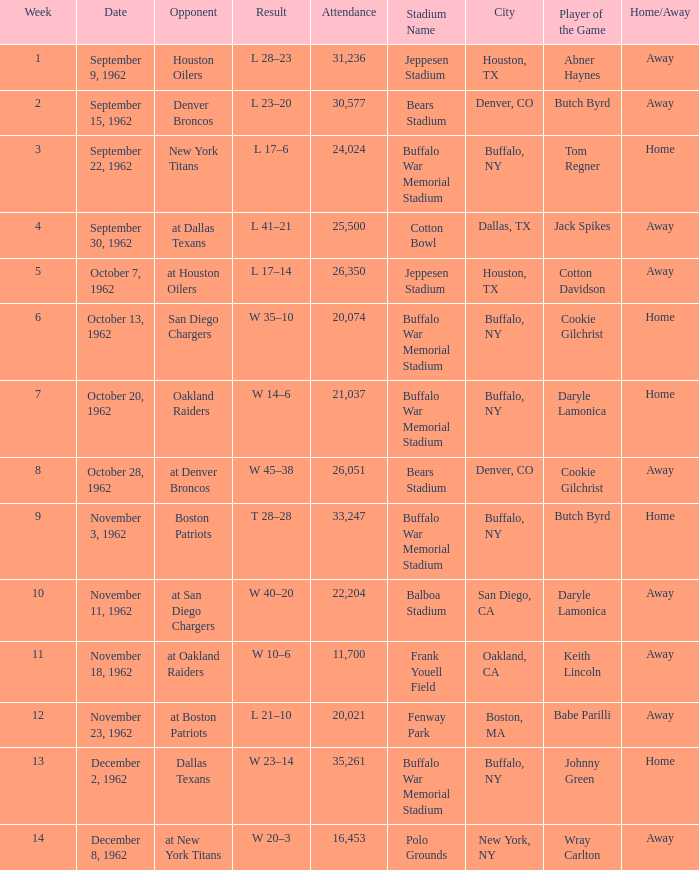What week was the attendance smaller than 22,204 on December 8, 1962? 14.0. 